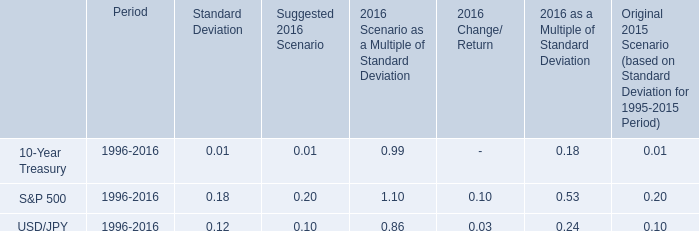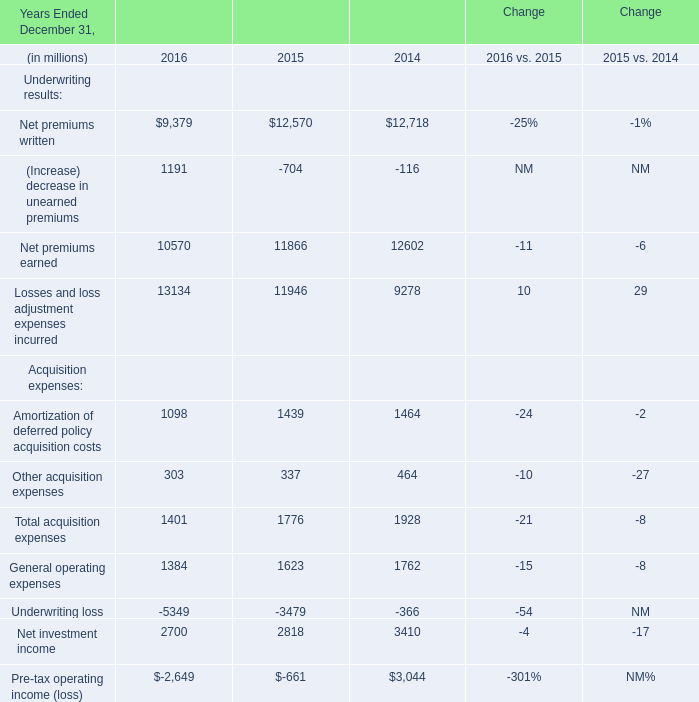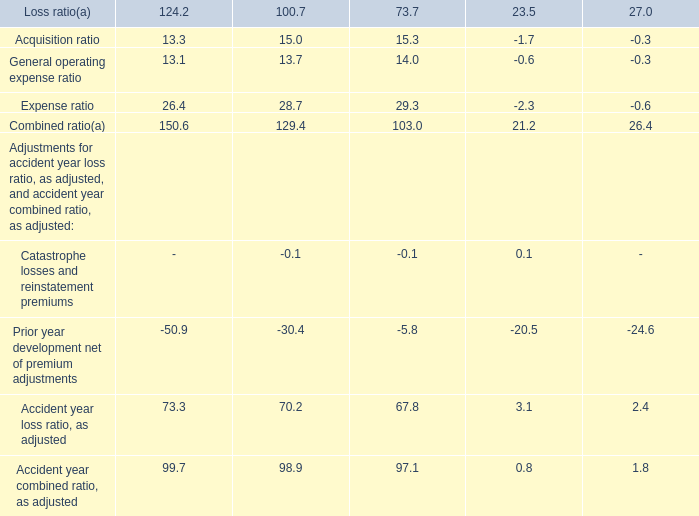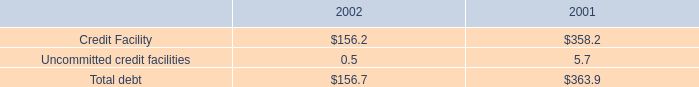what was the percentage change of total debt from 2001 to 2002? 
Computations: ((156.7 - 363.9) / 363.9)
Answer: -0.56939. 